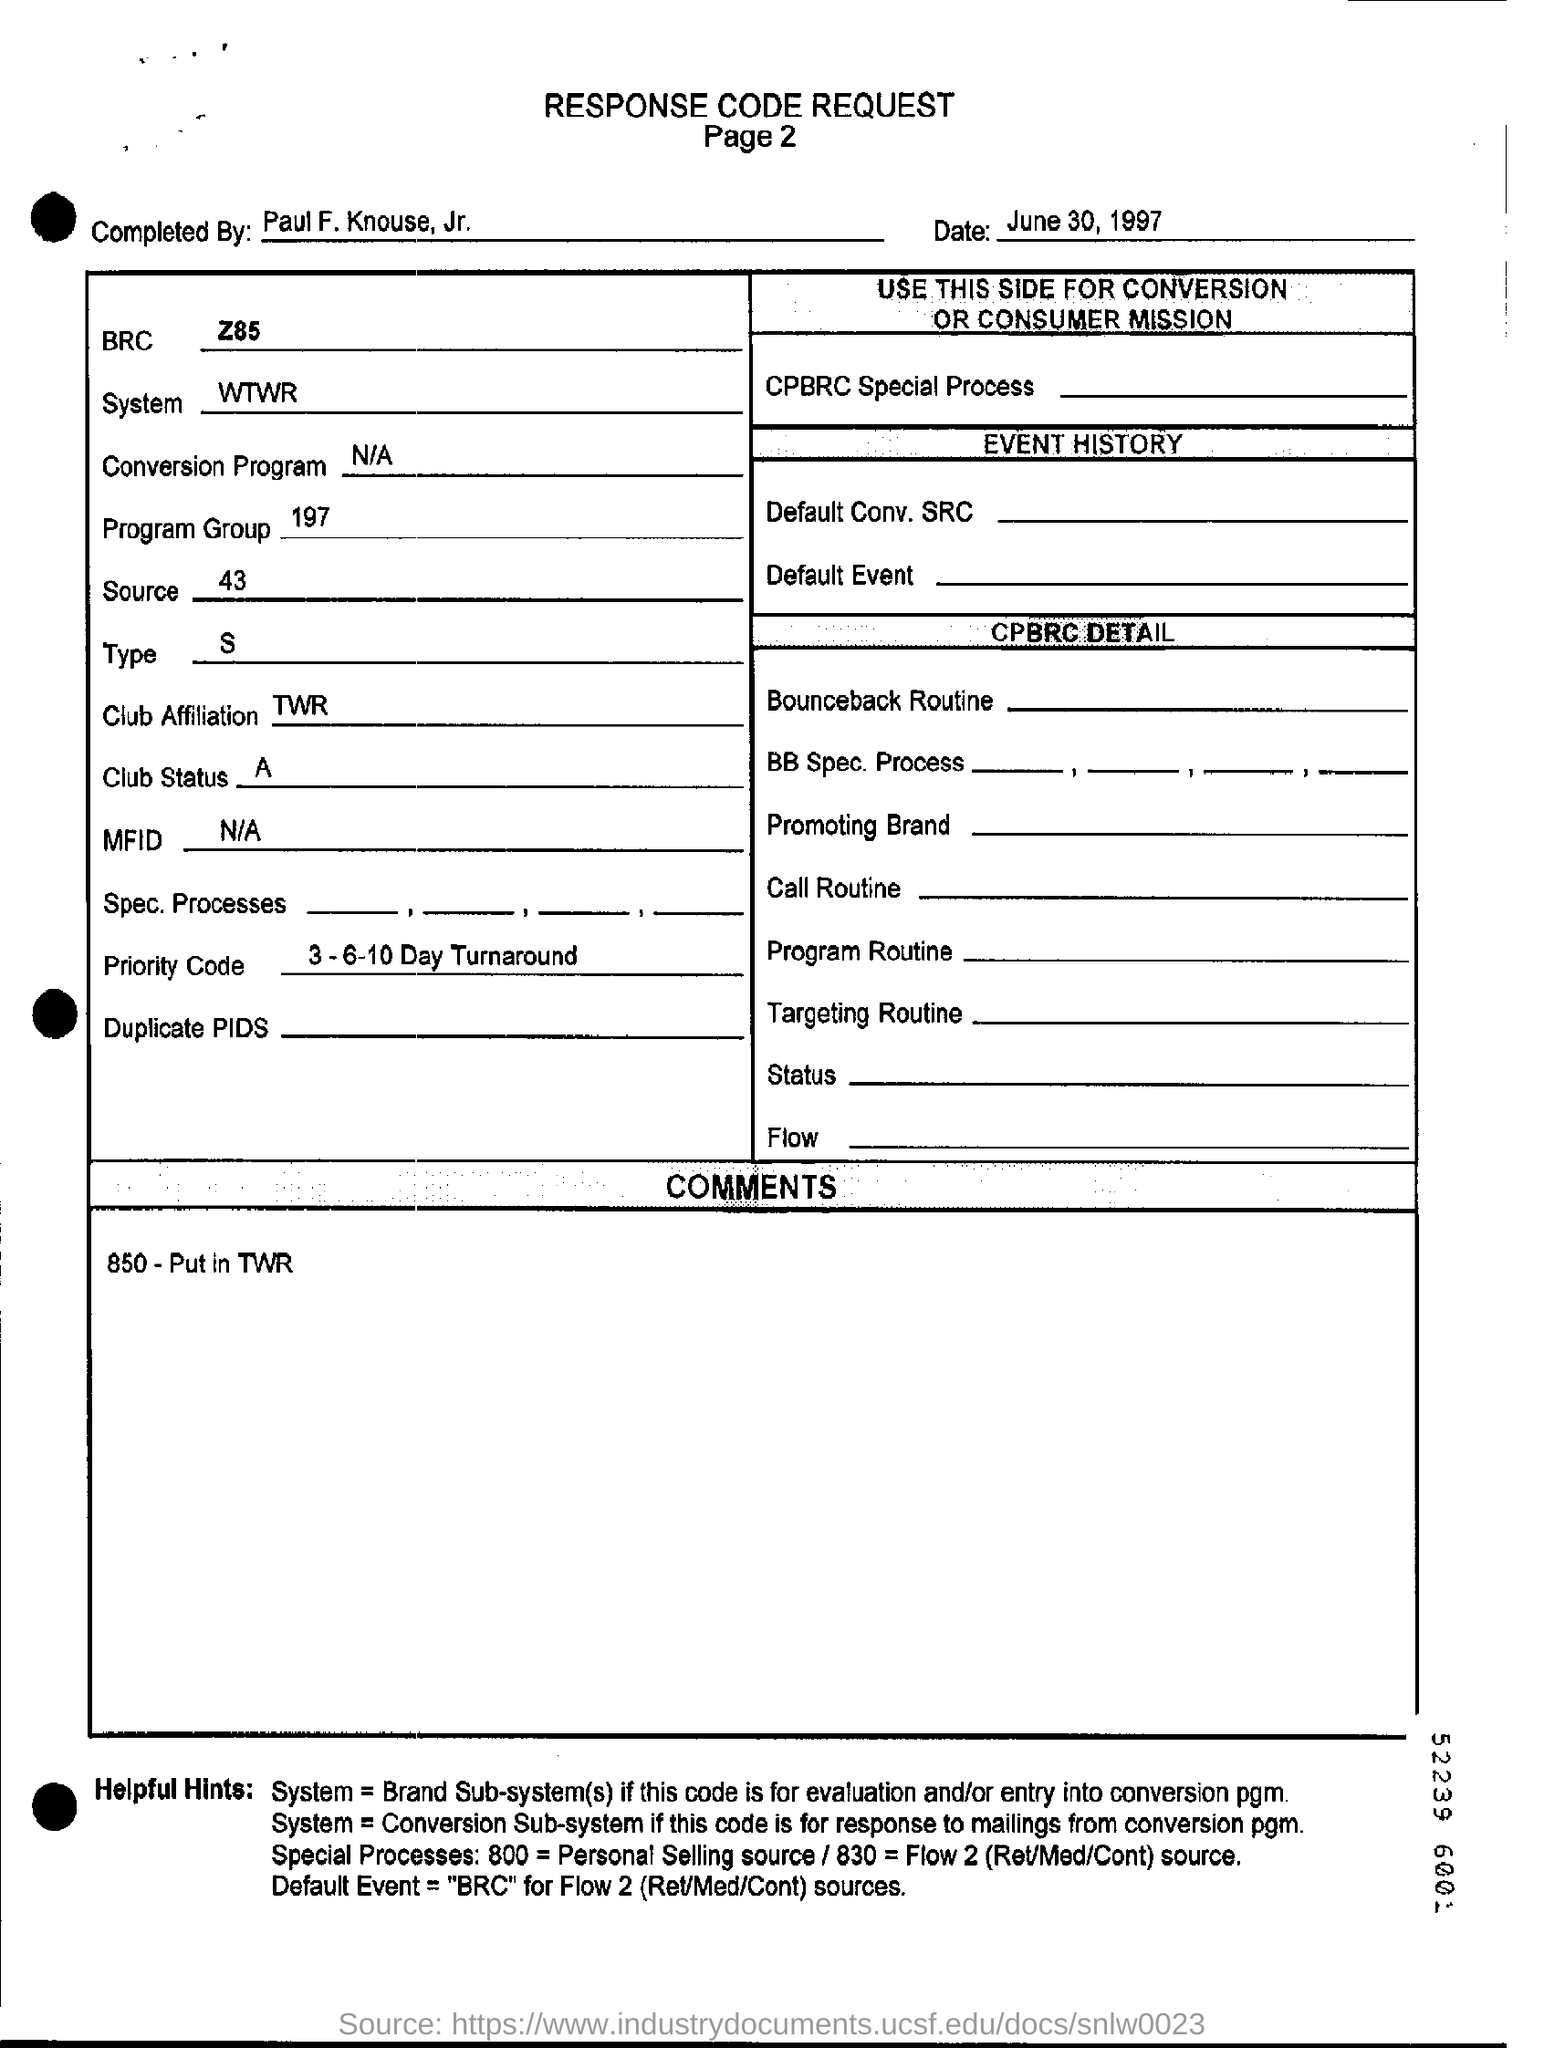Who completed the given response code request?
Ensure brevity in your answer.  Paul F. Knouse, Jr. What is the date of this response code request?
Your answer should be very brief. June 30, 1997. What is the name of system in given document?
Ensure brevity in your answer.  WTWR. What is the club status?
Your response must be concise. A. What is written in the "COMMENTS" box?
Make the answer very short. 850 - Put in TWR. 